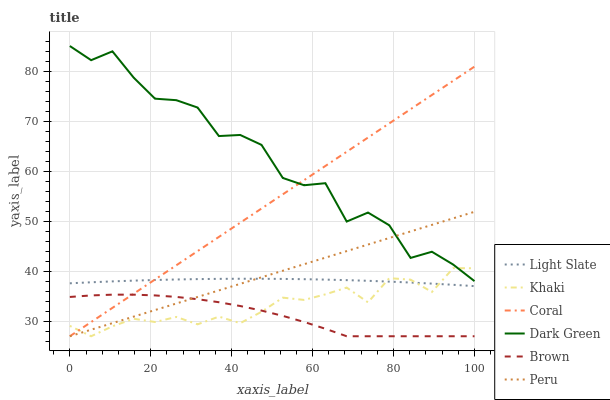Does Brown have the minimum area under the curve?
Answer yes or no. Yes. Does Dark Green have the maximum area under the curve?
Answer yes or no. Yes. Does Khaki have the minimum area under the curve?
Answer yes or no. No. Does Khaki have the maximum area under the curve?
Answer yes or no. No. Is Coral the smoothest?
Answer yes or no. Yes. Is Dark Green the roughest?
Answer yes or no. Yes. Is Khaki the smoothest?
Answer yes or no. No. Is Khaki the roughest?
Answer yes or no. No. Does Brown have the lowest value?
Answer yes or no. Yes. Does Light Slate have the lowest value?
Answer yes or no. No. Does Dark Green have the highest value?
Answer yes or no. Yes. Does Khaki have the highest value?
Answer yes or no. No. Is Brown less than Light Slate?
Answer yes or no. Yes. Is Dark Green greater than Brown?
Answer yes or no. Yes. Does Coral intersect Khaki?
Answer yes or no. Yes. Is Coral less than Khaki?
Answer yes or no. No. Is Coral greater than Khaki?
Answer yes or no. No. Does Brown intersect Light Slate?
Answer yes or no. No. 